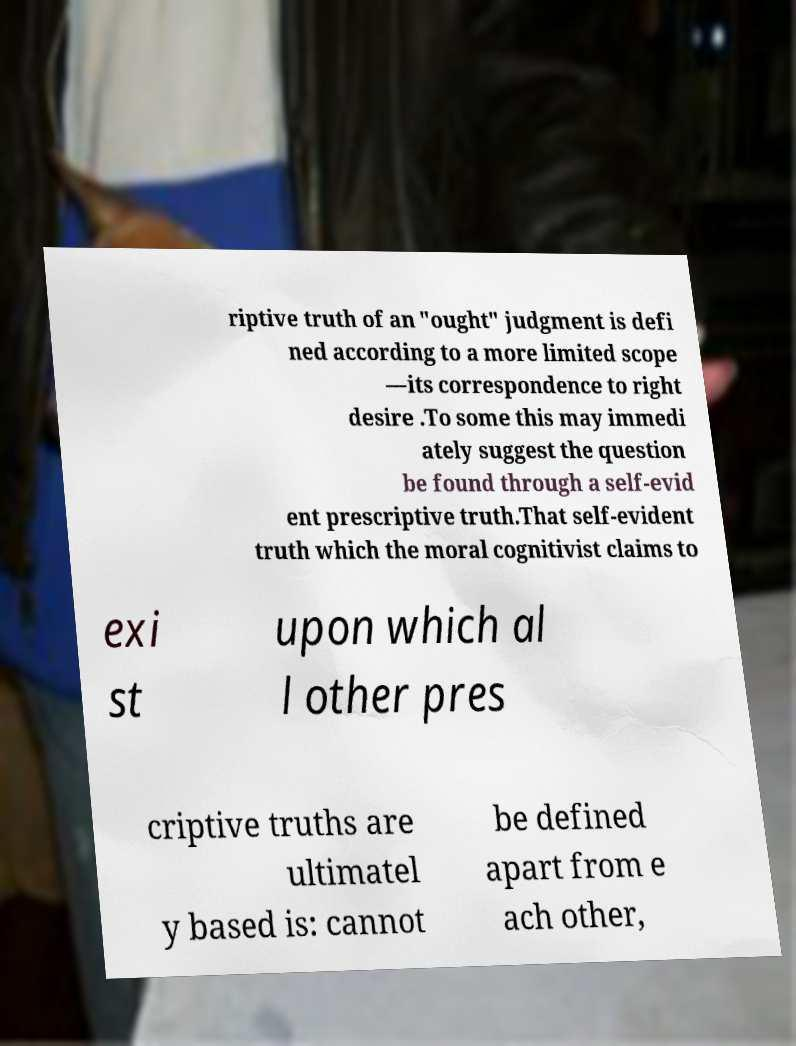Please identify and transcribe the text found in this image. riptive truth of an "ought" judgment is defi ned according to a more limited scope —its correspondence to right desire .To some this may immedi ately suggest the question be found through a self-evid ent prescriptive truth.That self-evident truth which the moral cognitivist claims to exi st upon which al l other pres criptive truths are ultimatel y based is: cannot be defined apart from e ach other, 